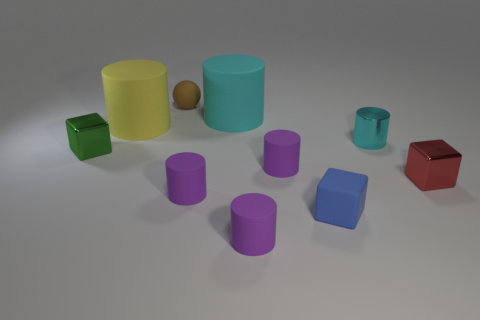Are there fewer rubber things than objects?
Offer a terse response. Yes. What number of rubber objects are tiny things or brown cubes?
Provide a short and direct response. 5. Are there any shiny things that are to the left of the tiny cylinder that is on the right side of the blue block?
Offer a very short reply. Yes. Is the material of the thing in front of the small rubber block the same as the tiny cyan thing?
Make the answer very short. No. What number of other things are the same color as the metallic cylinder?
Make the answer very short. 1. How big is the metallic block that is on the right side of the small matte thing that is behind the small green thing?
Provide a short and direct response. Small. Are the small purple cylinder that is behind the red metal thing and the large cylinder that is left of the small brown thing made of the same material?
Your response must be concise. Yes. Do the large rubber thing that is on the right side of the brown object and the small metallic cylinder have the same color?
Make the answer very short. Yes. There is a small cyan cylinder; how many cyan metallic things are behind it?
Make the answer very short. 0. Do the small green block and the large thing that is to the left of the small matte ball have the same material?
Keep it short and to the point. No. 